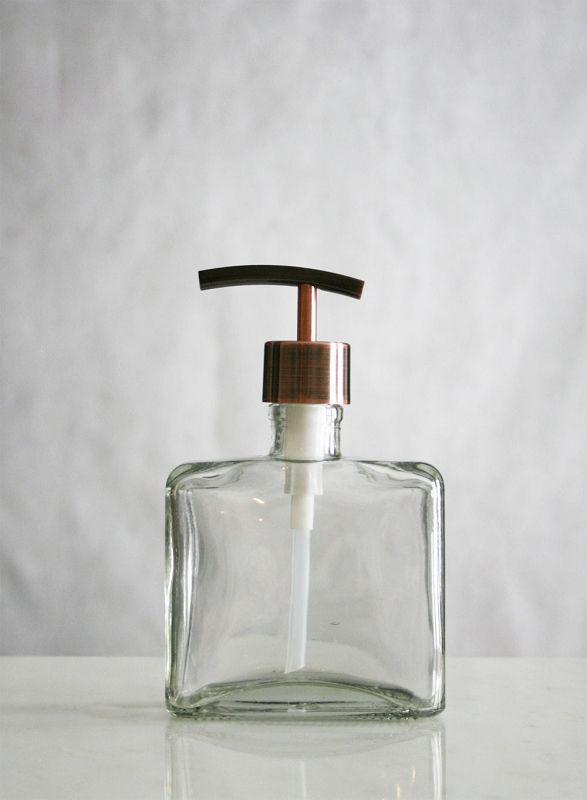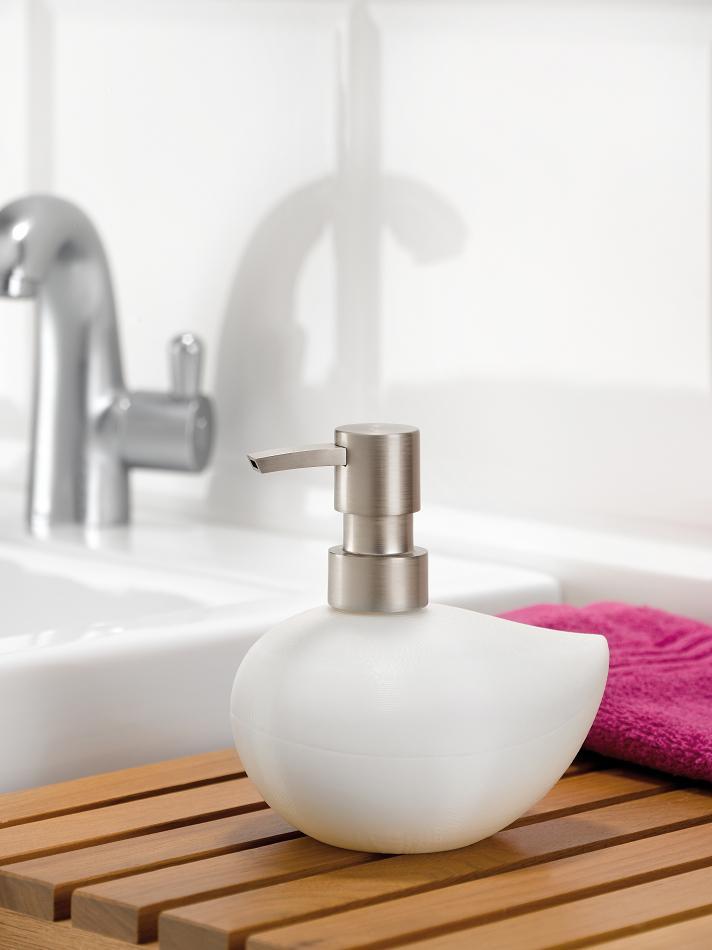The first image is the image on the left, the second image is the image on the right. Considering the images on both sides, is "At least one soap dispenser has a spout pointing to the left." valid? Answer yes or no. Yes. 